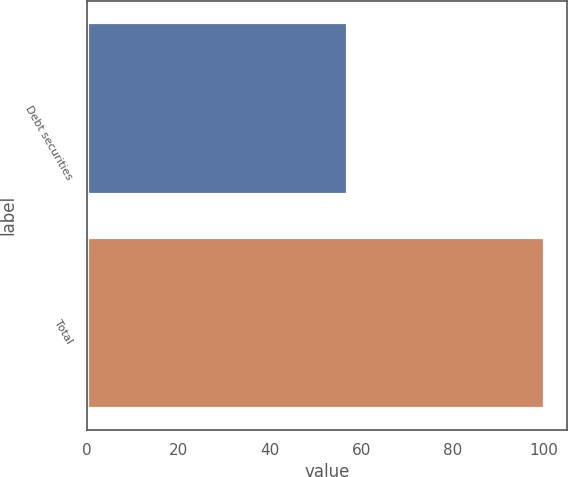<chart> <loc_0><loc_0><loc_500><loc_500><bar_chart><fcel>Debt securities<fcel>Total<nl><fcel>57<fcel>100<nl></chart> 